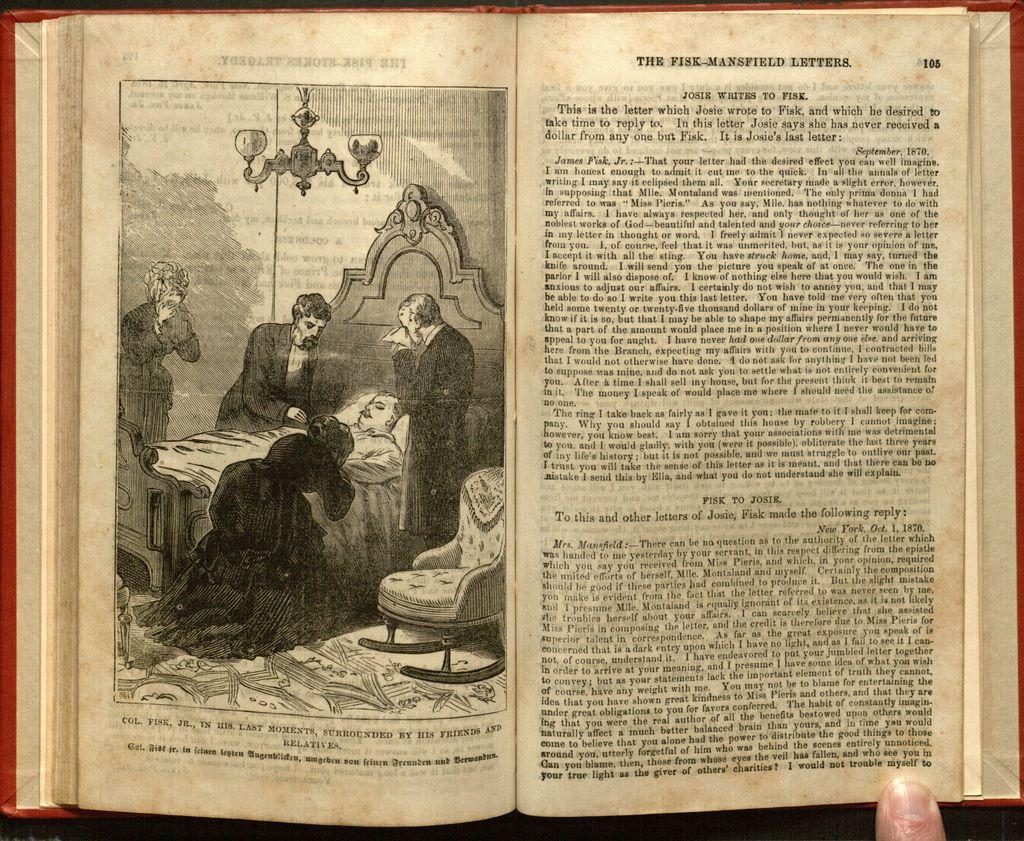What is the main subject of the photograph in the image? There is a photograph of an old book in the image. What is the man on the bed doing? The man is lying on the bed. What are the people standing beside the bed doing? The people standing beside the bed appear to be crying. How many trees can be seen in the image? There are no trees visible in the image; it features a photograph of an old book, a man lying on a bed, and people standing beside the bed. What type of nut is being used as a prop in the image? There is no nut present in the image. 